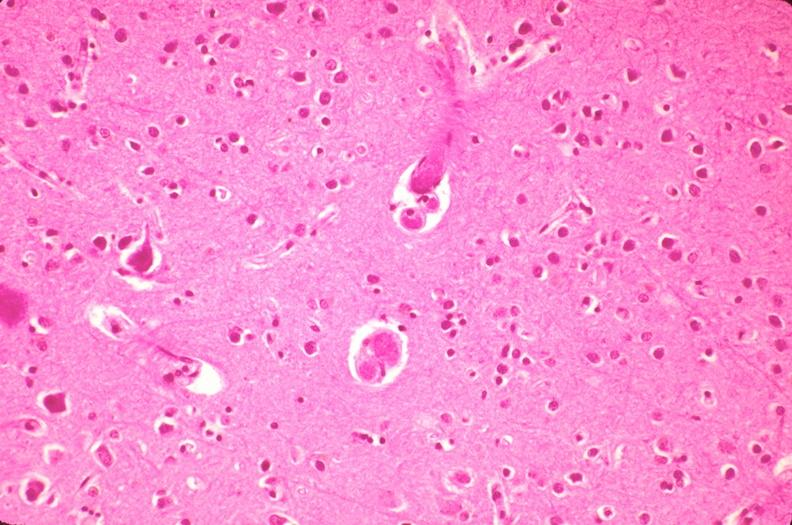does this image show brain, microthrombi, thrombotic thrombocytopenic purpura?
Answer the question using a single word or phrase. Yes 